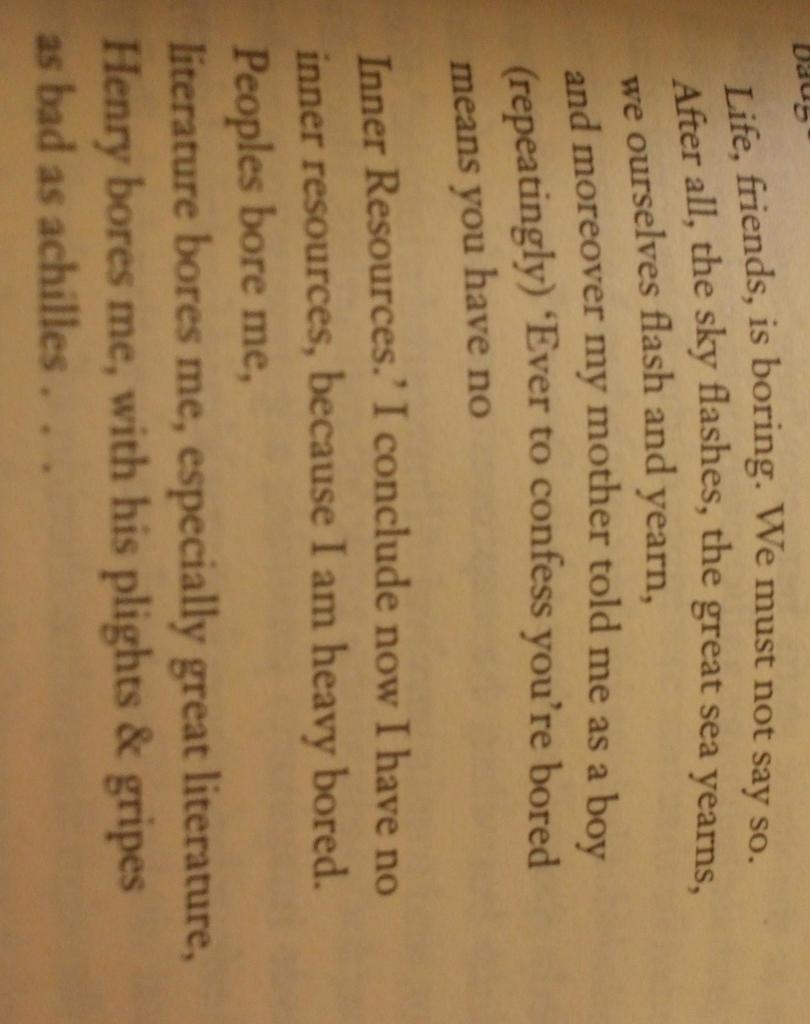What is written on in the image? There is text on a paper in the image. How many cherries are on the paper in the image? There is no mention of cherries in the image; the only subject mentioned is text on a paper. 